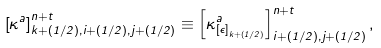<formula> <loc_0><loc_0><loc_500><loc_500>\left [ \kappa ^ { a } \right ] ^ { n + t } _ { k + ( 1 / 2 ) , i + ( 1 / 2 ) , j + ( 1 / 2 ) } \equiv \left [ \kappa ^ { a } _ { \left [ \epsilon \right ] _ { k + ( 1 / 2 ) } } \right ] ^ { n + t } _ { i + ( 1 / 2 ) , j + ( 1 / 2 ) } ,</formula> 